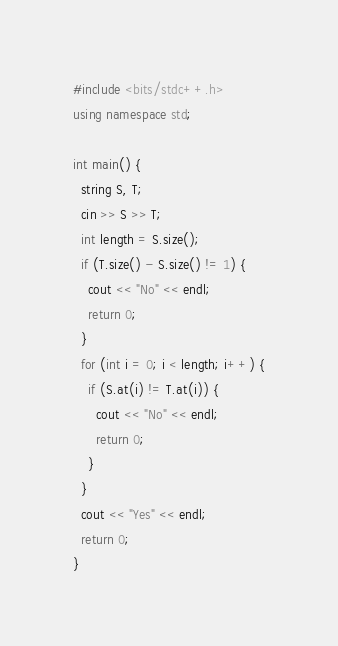Convert code to text. <code><loc_0><loc_0><loc_500><loc_500><_C++_>#include <bits/stdc++.h>
using namespace std;

int main() {
  string S, T;
  cin >> S >> T;
  int length = S.size();
  if (T.size() - S.size() != 1) {
    cout << "No" << endl;
    return 0;
  }
  for (int i = 0; i < length; i++) {
    if (S.at(i) != T.at(i)) {
      cout << "No" << endl;
      return 0;
    }
  }
  cout << "Yes" << endl;
  return 0;
}</code> 